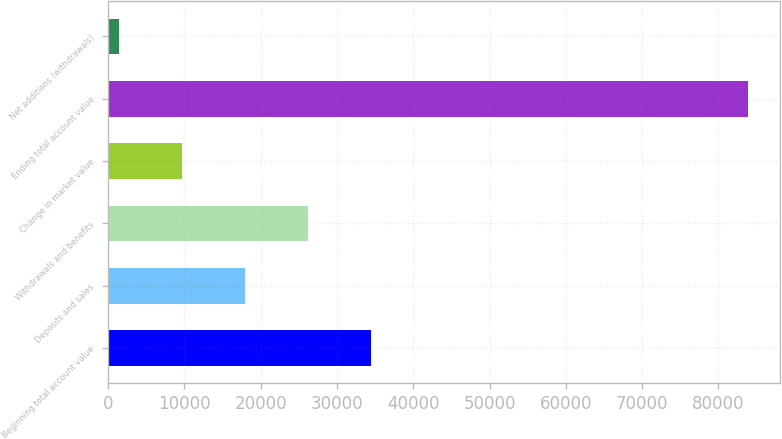<chart> <loc_0><loc_0><loc_500><loc_500><bar_chart><fcel>Beginning total account value<fcel>Deposits and sales<fcel>Withdrawals and benefits<fcel>Change in market value<fcel>Ending total account value<fcel>Net additions (withdrawals)<nl><fcel>34409.6<fcel>17915.8<fcel>26162.7<fcel>9668.9<fcel>83891<fcel>1422<nl></chart> 